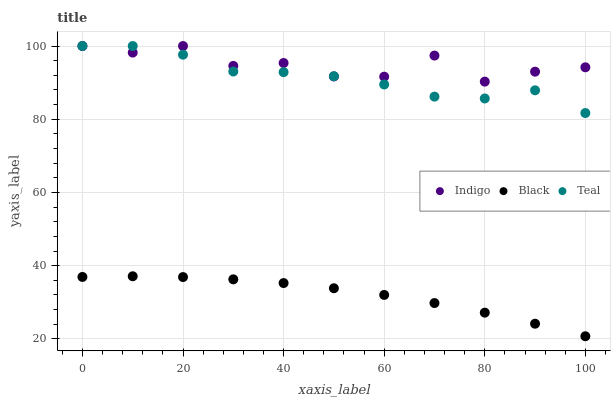Does Black have the minimum area under the curve?
Answer yes or no. Yes. Does Indigo have the maximum area under the curve?
Answer yes or no. Yes. Does Teal have the minimum area under the curve?
Answer yes or no. No. Does Teal have the maximum area under the curve?
Answer yes or no. No. Is Black the smoothest?
Answer yes or no. Yes. Is Indigo the roughest?
Answer yes or no. Yes. Is Teal the smoothest?
Answer yes or no. No. Is Teal the roughest?
Answer yes or no. No. Does Black have the lowest value?
Answer yes or no. Yes. Does Teal have the lowest value?
Answer yes or no. No. Does Teal have the highest value?
Answer yes or no. Yes. Is Black less than Indigo?
Answer yes or no. Yes. Is Indigo greater than Black?
Answer yes or no. Yes. Does Teal intersect Indigo?
Answer yes or no. Yes. Is Teal less than Indigo?
Answer yes or no. No. Is Teal greater than Indigo?
Answer yes or no. No. Does Black intersect Indigo?
Answer yes or no. No. 